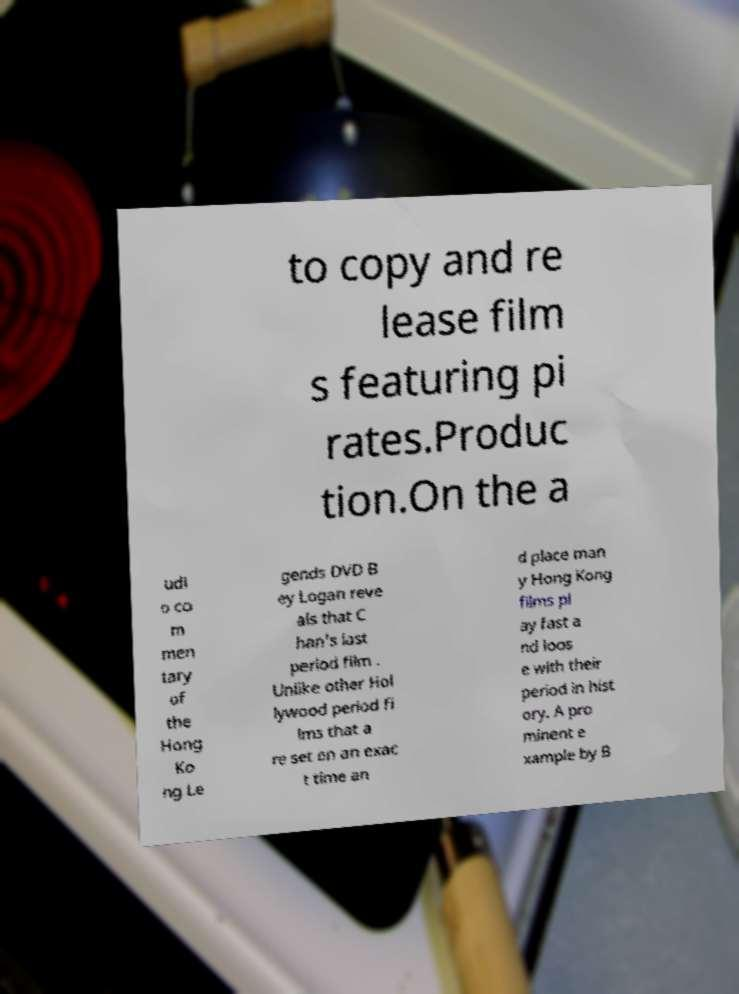For documentation purposes, I need the text within this image transcribed. Could you provide that? to copy and re lease film s featuring pi rates.Produc tion.On the a udi o co m men tary of the Hong Ko ng Le gends DVD B ey Logan reve als that C han's last period film . Unlike other Hol lywood period fi lms that a re set on an exac t time an d place man y Hong Kong films pl ay fast a nd loos e with their period in hist ory. A pro minent e xample by B 